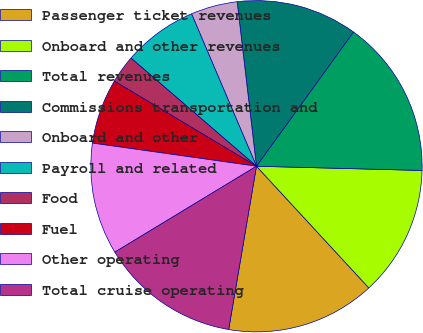Convert chart to OTSL. <chart><loc_0><loc_0><loc_500><loc_500><pie_chart><fcel>Passenger ticket revenues<fcel>Onboard and other revenues<fcel>Total revenues<fcel>Commissions transportation and<fcel>Onboard and other<fcel>Payroll and related<fcel>Food<fcel>Fuel<fcel>Other operating<fcel>Total cruise operating<nl><fcel>14.55%<fcel>12.73%<fcel>15.45%<fcel>11.82%<fcel>4.55%<fcel>7.27%<fcel>2.73%<fcel>6.36%<fcel>10.91%<fcel>13.64%<nl></chart> 